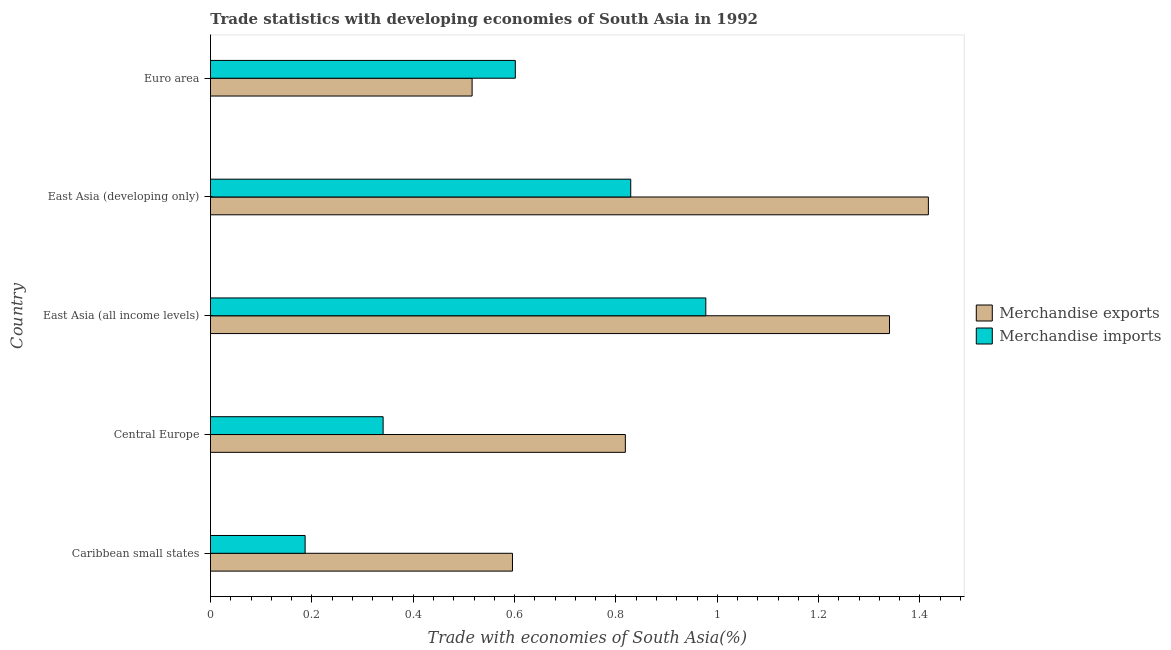How many different coloured bars are there?
Ensure brevity in your answer.  2. Are the number of bars on each tick of the Y-axis equal?
Offer a terse response. Yes. How many bars are there on the 3rd tick from the top?
Offer a terse response. 2. What is the label of the 3rd group of bars from the top?
Your answer should be compact. East Asia (all income levels). What is the merchandise exports in East Asia (developing only)?
Ensure brevity in your answer.  1.42. Across all countries, what is the maximum merchandise exports?
Keep it short and to the point. 1.42. Across all countries, what is the minimum merchandise imports?
Make the answer very short. 0.19. In which country was the merchandise exports maximum?
Your answer should be compact. East Asia (developing only). What is the total merchandise exports in the graph?
Your answer should be very brief. 4.69. What is the difference between the merchandise exports in East Asia (developing only) and that in Euro area?
Offer a very short reply. 0.9. What is the difference between the merchandise imports in Central Europe and the merchandise exports in East Asia (all income levels)?
Your answer should be compact. -1. What is the average merchandise imports per country?
Offer a terse response. 0.59. What is the difference between the merchandise imports and merchandise exports in Euro area?
Make the answer very short. 0.09. What is the ratio of the merchandise imports in Central Europe to that in East Asia (developing only)?
Make the answer very short. 0.41. Is the merchandise exports in Central Europe less than that in East Asia (all income levels)?
Provide a succinct answer. Yes. What is the difference between the highest and the second highest merchandise exports?
Make the answer very short. 0.08. What is the difference between the highest and the lowest merchandise exports?
Offer a very short reply. 0.9. What does the 1st bar from the top in Euro area represents?
Keep it short and to the point. Merchandise imports. What does the 2nd bar from the bottom in Caribbean small states represents?
Your response must be concise. Merchandise imports. How many bars are there?
Give a very brief answer. 10. Are all the bars in the graph horizontal?
Offer a very short reply. Yes. How many countries are there in the graph?
Your answer should be compact. 5. What is the difference between two consecutive major ticks on the X-axis?
Offer a terse response. 0.2. Are the values on the major ticks of X-axis written in scientific E-notation?
Offer a terse response. No. Does the graph contain any zero values?
Make the answer very short. No. How many legend labels are there?
Provide a short and direct response. 2. How are the legend labels stacked?
Offer a very short reply. Vertical. What is the title of the graph?
Give a very brief answer. Trade statistics with developing economies of South Asia in 1992. Does "Health Care" appear as one of the legend labels in the graph?
Provide a succinct answer. No. What is the label or title of the X-axis?
Give a very brief answer. Trade with economies of South Asia(%). What is the label or title of the Y-axis?
Provide a succinct answer. Country. What is the Trade with economies of South Asia(%) of Merchandise exports in Caribbean small states?
Provide a short and direct response. 0.6. What is the Trade with economies of South Asia(%) in Merchandise imports in Caribbean small states?
Ensure brevity in your answer.  0.19. What is the Trade with economies of South Asia(%) of Merchandise exports in Central Europe?
Keep it short and to the point. 0.82. What is the Trade with economies of South Asia(%) of Merchandise imports in Central Europe?
Make the answer very short. 0.34. What is the Trade with economies of South Asia(%) in Merchandise exports in East Asia (all income levels)?
Keep it short and to the point. 1.34. What is the Trade with economies of South Asia(%) in Merchandise imports in East Asia (all income levels)?
Your answer should be compact. 0.98. What is the Trade with economies of South Asia(%) of Merchandise exports in East Asia (developing only)?
Offer a very short reply. 1.42. What is the Trade with economies of South Asia(%) in Merchandise imports in East Asia (developing only)?
Your answer should be compact. 0.83. What is the Trade with economies of South Asia(%) in Merchandise exports in Euro area?
Ensure brevity in your answer.  0.52. What is the Trade with economies of South Asia(%) in Merchandise imports in Euro area?
Your answer should be very brief. 0.6. Across all countries, what is the maximum Trade with economies of South Asia(%) of Merchandise exports?
Your response must be concise. 1.42. Across all countries, what is the maximum Trade with economies of South Asia(%) of Merchandise imports?
Your answer should be very brief. 0.98. Across all countries, what is the minimum Trade with economies of South Asia(%) in Merchandise exports?
Give a very brief answer. 0.52. Across all countries, what is the minimum Trade with economies of South Asia(%) in Merchandise imports?
Provide a short and direct response. 0.19. What is the total Trade with economies of South Asia(%) of Merchandise exports in the graph?
Provide a succinct answer. 4.69. What is the total Trade with economies of South Asia(%) of Merchandise imports in the graph?
Keep it short and to the point. 2.94. What is the difference between the Trade with economies of South Asia(%) in Merchandise exports in Caribbean small states and that in Central Europe?
Provide a succinct answer. -0.22. What is the difference between the Trade with economies of South Asia(%) in Merchandise imports in Caribbean small states and that in Central Europe?
Offer a very short reply. -0.15. What is the difference between the Trade with economies of South Asia(%) in Merchandise exports in Caribbean small states and that in East Asia (all income levels)?
Provide a short and direct response. -0.74. What is the difference between the Trade with economies of South Asia(%) in Merchandise imports in Caribbean small states and that in East Asia (all income levels)?
Your answer should be compact. -0.79. What is the difference between the Trade with economies of South Asia(%) of Merchandise exports in Caribbean small states and that in East Asia (developing only)?
Your response must be concise. -0.82. What is the difference between the Trade with economies of South Asia(%) of Merchandise imports in Caribbean small states and that in East Asia (developing only)?
Make the answer very short. -0.64. What is the difference between the Trade with economies of South Asia(%) in Merchandise exports in Caribbean small states and that in Euro area?
Ensure brevity in your answer.  0.08. What is the difference between the Trade with economies of South Asia(%) of Merchandise imports in Caribbean small states and that in Euro area?
Give a very brief answer. -0.41. What is the difference between the Trade with economies of South Asia(%) of Merchandise exports in Central Europe and that in East Asia (all income levels)?
Provide a succinct answer. -0.52. What is the difference between the Trade with economies of South Asia(%) of Merchandise imports in Central Europe and that in East Asia (all income levels)?
Provide a succinct answer. -0.64. What is the difference between the Trade with economies of South Asia(%) in Merchandise exports in Central Europe and that in East Asia (developing only)?
Your answer should be very brief. -0.6. What is the difference between the Trade with economies of South Asia(%) of Merchandise imports in Central Europe and that in East Asia (developing only)?
Make the answer very short. -0.49. What is the difference between the Trade with economies of South Asia(%) of Merchandise exports in Central Europe and that in Euro area?
Make the answer very short. 0.3. What is the difference between the Trade with economies of South Asia(%) in Merchandise imports in Central Europe and that in Euro area?
Your response must be concise. -0.26. What is the difference between the Trade with economies of South Asia(%) of Merchandise exports in East Asia (all income levels) and that in East Asia (developing only)?
Give a very brief answer. -0.08. What is the difference between the Trade with economies of South Asia(%) of Merchandise imports in East Asia (all income levels) and that in East Asia (developing only)?
Provide a short and direct response. 0.15. What is the difference between the Trade with economies of South Asia(%) in Merchandise exports in East Asia (all income levels) and that in Euro area?
Provide a succinct answer. 0.82. What is the difference between the Trade with economies of South Asia(%) of Merchandise imports in East Asia (all income levels) and that in Euro area?
Provide a short and direct response. 0.38. What is the difference between the Trade with economies of South Asia(%) in Merchandise exports in East Asia (developing only) and that in Euro area?
Keep it short and to the point. 0.9. What is the difference between the Trade with economies of South Asia(%) in Merchandise imports in East Asia (developing only) and that in Euro area?
Give a very brief answer. 0.23. What is the difference between the Trade with economies of South Asia(%) of Merchandise exports in Caribbean small states and the Trade with economies of South Asia(%) of Merchandise imports in Central Europe?
Make the answer very short. 0.26. What is the difference between the Trade with economies of South Asia(%) in Merchandise exports in Caribbean small states and the Trade with economies of South Asia(%) in Merchandise imports in East Asia (all income levels)?
Give a very brief answer. -0.38. What is the difference between the Trade with economies of South Asia(%) of Merchandise exports in Caribbean small states and the Trade with economies of South Asia(%) of Merchandise imports in East Asia (developing only)?
Your answer should be very brief. -0.23. What is the difference between the Trade with economies of South Asia(%) of Merchandise exports in Caribbean small states and the Trade with economies of South Asia(%) of Merchandise imports in Euro area?
Your response must be concise. -0.01. What is the difference between the Trade with economies of South Asia(%) in Merchandise exports in Central Europe and the Trade with economies of South Asia(%) in Merchandise imports in East Asia (all income levels)?
Offer a terse response. -0.16. What is the difference between the Trade with economies of South Asia(%) of Merchandise exports in Central Europe and the Trade with economies of South Asia(%) of Merchandise imports in East Asia (developing only)?
Keep it short and to the point. -0.01. What is the difference between the Trade with economies of South Asia(%) of Merchandise exports in Central Europe and the Trade with economies of South Asia(%) of Merchandise imports in Euro area?
Your answer should be very brief. 0.22. What is the difference between the Trade with economies of South Asia(%) of Merchandise exports in East Asia (all income levels) and the Trade with economies of South Asia(%) of Merchandise imports in East Asia (developing only)?
Your answer should be very brief. 0.51. What is the difference between the Trade with economies of South Asia(%) in Merchandise exports in East Asia (all income levels) and the Trade with economies of South Asia(%) in Merchandise imports in Euro area?
Provide a short and direct response. 0.74. What is the difference between the Trade with economies of South Asia(%) of Merchandise exports in East Asia (developing only) and the Trade with economies of South Asia(%) of Merchandise imports in Euro area?
Keep it short and to the point. 0.81. What is the average Trade with economies of South Asia(%) in Merchandise exports per country?
Make the answer very short. 0.94. What is the average Trade with economies of South Asia(%) in Merchandise imports per country?
Keep it short and to the point. 0.59. What is the difference between the Trade with economies of South Asia(%) in Merchandise exports and Trade with economies of South Asia(%) in Merchandise imports in Caribbean small states?
Your response must be concise. 0.41. What is the difference between the Trade with economies of South Asia(%) of Merchandise exports and Trade with economies of South Asia(%) of Merchandise imports in Central Europe?
Offer a terse response. 0.48. What is the difference between the Trade with economies of South Asia(%) in Merchandise exports and Trade with economies of South Asia(%) in Merchandise imports in East Asia (all income levels)?
Offer a terse response. 0.36. What is the difference between the Trade with economies of South Asia(%) in Merchandise exports and Trade with economies of South Asia(%) in Merchandise imports in East Asia (developing only)?
Ensure brevity in your answer.  0.59. What is the difference between the Trade with economies of South Asia(%) of Merchandise exports and Trade with economies of South Asia(%) of Merchandise imports in Euro area?
Provide a succinct answer. -0.09. What is the ratio of the Trade with economies of South Asia(%) in Merchandise exports in Caribbean small states to that in Central Europe?
Your answer should be compact. 0.73. What is the ratio of the Trade with economies of South Asia(%) in Merchandise imports in Caribbean small states to that in Central Europe?
Ensure brevity in your answer.  0.55. What is the ratio of the Trade with economies of South Asia(%) of Merchandise exports in Caribbean small states to that in East Asia (all income levels)?
Keep it short and to the point. 0.44. What is the ratio of the Trade with economies of South Asia(%) in Merchandise imports in Caribbean small states to that in East Asia (all income levels)?
Offer a terse response. 0.19. What is the ratio of the Trade with economies of South Asia(%) in Merchandise exports in Caribbean small states to that in East Asia (developing only)?
Offer a terse response. 0.42. What is the ratio of the Trade with economies of South Asia(%) in Merchandise imports in Caribbean small states to that in East Asia (developing only)?
Provide a short and direct response. 0.23. What is the ratio of the Trade with economies of South Asia(%) in Merchandise exports in Caribbean small states to that in Euro area?
Make the answer very short. 1.15. What is the ratio of the Trade with economies of South Asia(%) in Merchandise imports in Caribbean small states to that in Euro area?
Your answer should be very brief. 0.31. What is the ratio of the Trade with economies of South Asia(%) in Merchandise exports in Central Europe to that in East Asia (all income levels)?
Provide a succinct answer. 0.61. What is the ratio of the Trade with economies of South Asia(%) of Merchandise imports in Central Europe to that in East Asia (all income levels)?
Provide a succinct answer. 0.35. What is the ratio of the Trade with economies of South Asia(%) in Merchandise exports in Central Europe to that in East Asia (developing only)?
Provide a short and direct response. 0.58. What is the ratio of the Trade with economies of South Asia(%) of Merchandise imports in Central Europe to that in East Asia (developing only)?
Your answer should be very brief. 0.41. What is the ratio of the Trade with economies of South Asia(%) in Merchandise exports in Central Europe to that in Euro area?
Keep it short and to the point. 1.59. What is the ratio of the Trade with economies of South Asia(%) of Merchandise imports in Central Europe to that in Euro area?
Your answer should be very brief. 0.57. What is the ratio of the Trade with economies of South Asia(%) in Merchandise exports in East Asia (all income levels) to that in East Asia (developing only)?
Offer a very short reply. 0.95. What is the ratio of the Trade with economies of South Asia(%) of Merchandise imports in East Asia (all income levels) to that in East Asia (developing only)?
Your response must be concise. 1.18. What is the ratio of the Trade with economies of South Asia(%) in Merchandise exports in East Asia (all income levels) to that in Euro area?
Offer a terse response. 2.6. What is the ratio of the Trade with economies of South Asia(%) of Merchandise imports in East Asia (all income levels) to that in Euro area?
Your answer should be very brief. 1.62. What is the ratio of the Trade with economies of South Asia(%) of Merchandise exports in East Asia (developing only) to that in Euro area?
Your answer should be compact. 2.74. What is the ratio of the Trade with economies of South Asia(%) of Merchandise imports in East Asia (developing only) to that in Euro area?
Provide a succinct answer. 1.38. What is the difference between the highest and the second highest Trade with economies of South Asia(%) in Merchandise exports?
Your answer should be compact. 0.08. What is the difference between the highest and the second highest Trade with economies of South Asia(%) in Merchandise imports?
Offer a very short reply. 0.15. What is the difference between the highest and the lowest Trade with economies of South Asia(%) in Merchandise exports?
Your answer should be very brief. 0.9. What is the difference between the highest and the lowest Trade with economies of South Asia(%) in Merchandise imports?
Offer a very short reply. 0.79. 